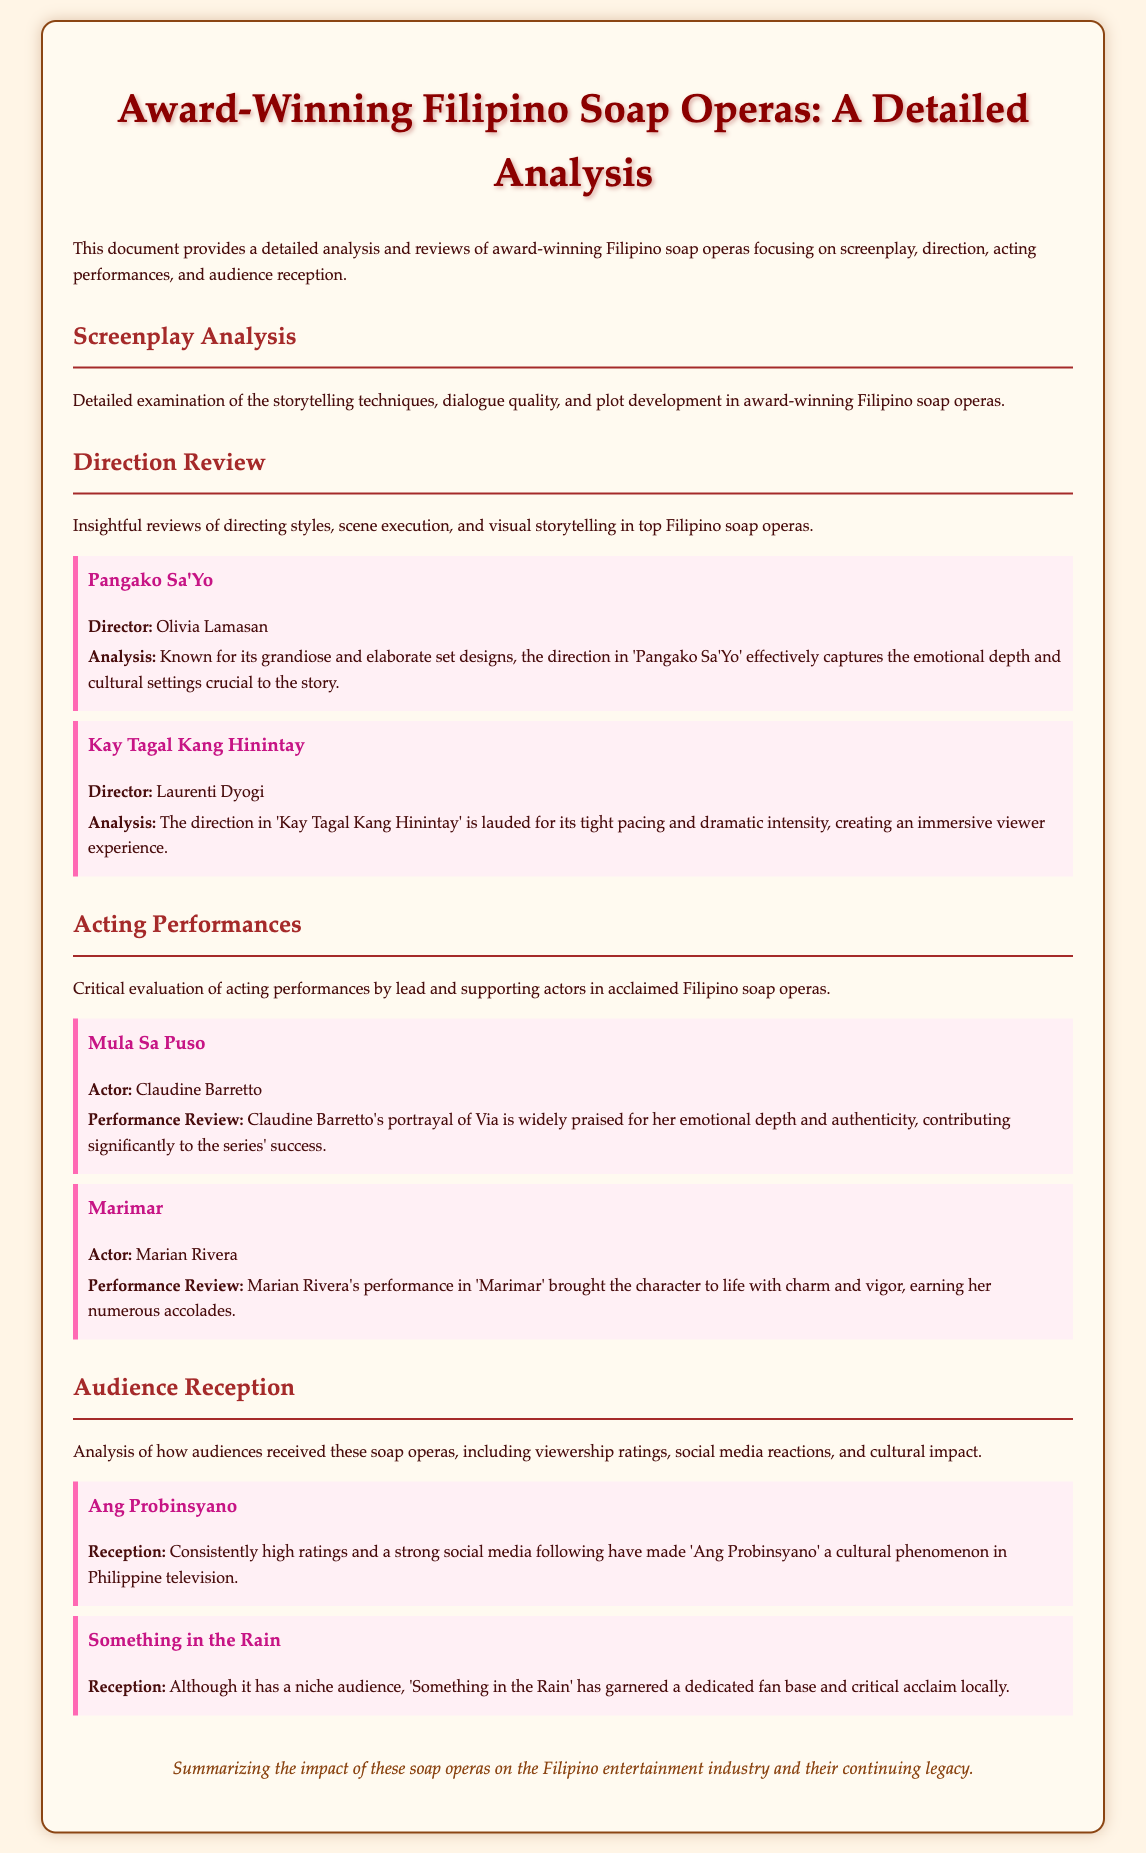what is the title of the document? The title of the document is prominently displayed at the top, indicating that it focuses on Filipino soap operas.
Answer: Award-Winning Filipino Soap Operas: A Detailed Analysis who directed 'Pangako Sa'Yo'? The document mentions the director of 'Pangako Sa'Yo' in the direction review section.
Answer: Olivia Lamasan what is the performance review for Claudine Barretto in 'Mula Sa Puso'? The document provides a specific evaluation of Claudine Barretto's performance, emphasizing her emotional depth.
Answer: emotional depth and authenticity what is the reception of 'Ang Probinsyano'? The document includes audience reception information regarding 'Ang Probinsyano'.
Answer: cultural phenomenon how are acting performances evaluated in the document? The document describes the criteria used for evaluating acting performances in Filipino soap operas.
Answer: Critical evaluation who directed 'Kay Tagal Kang Hinintay'? The document lists the director responsible for 'Kay Tagal Kang Hinintay'.
Answer: Laurenti Dyogi what genre do the discussed shows mainly belong to? The document focuses on a specific genre of television productions in the Philippines.
Answer: soap operas how is social media mentioned in relation to audience reception? The audience reception section includes information regarding the effect of social media on specific soap operas.
Answer: strong social media following 